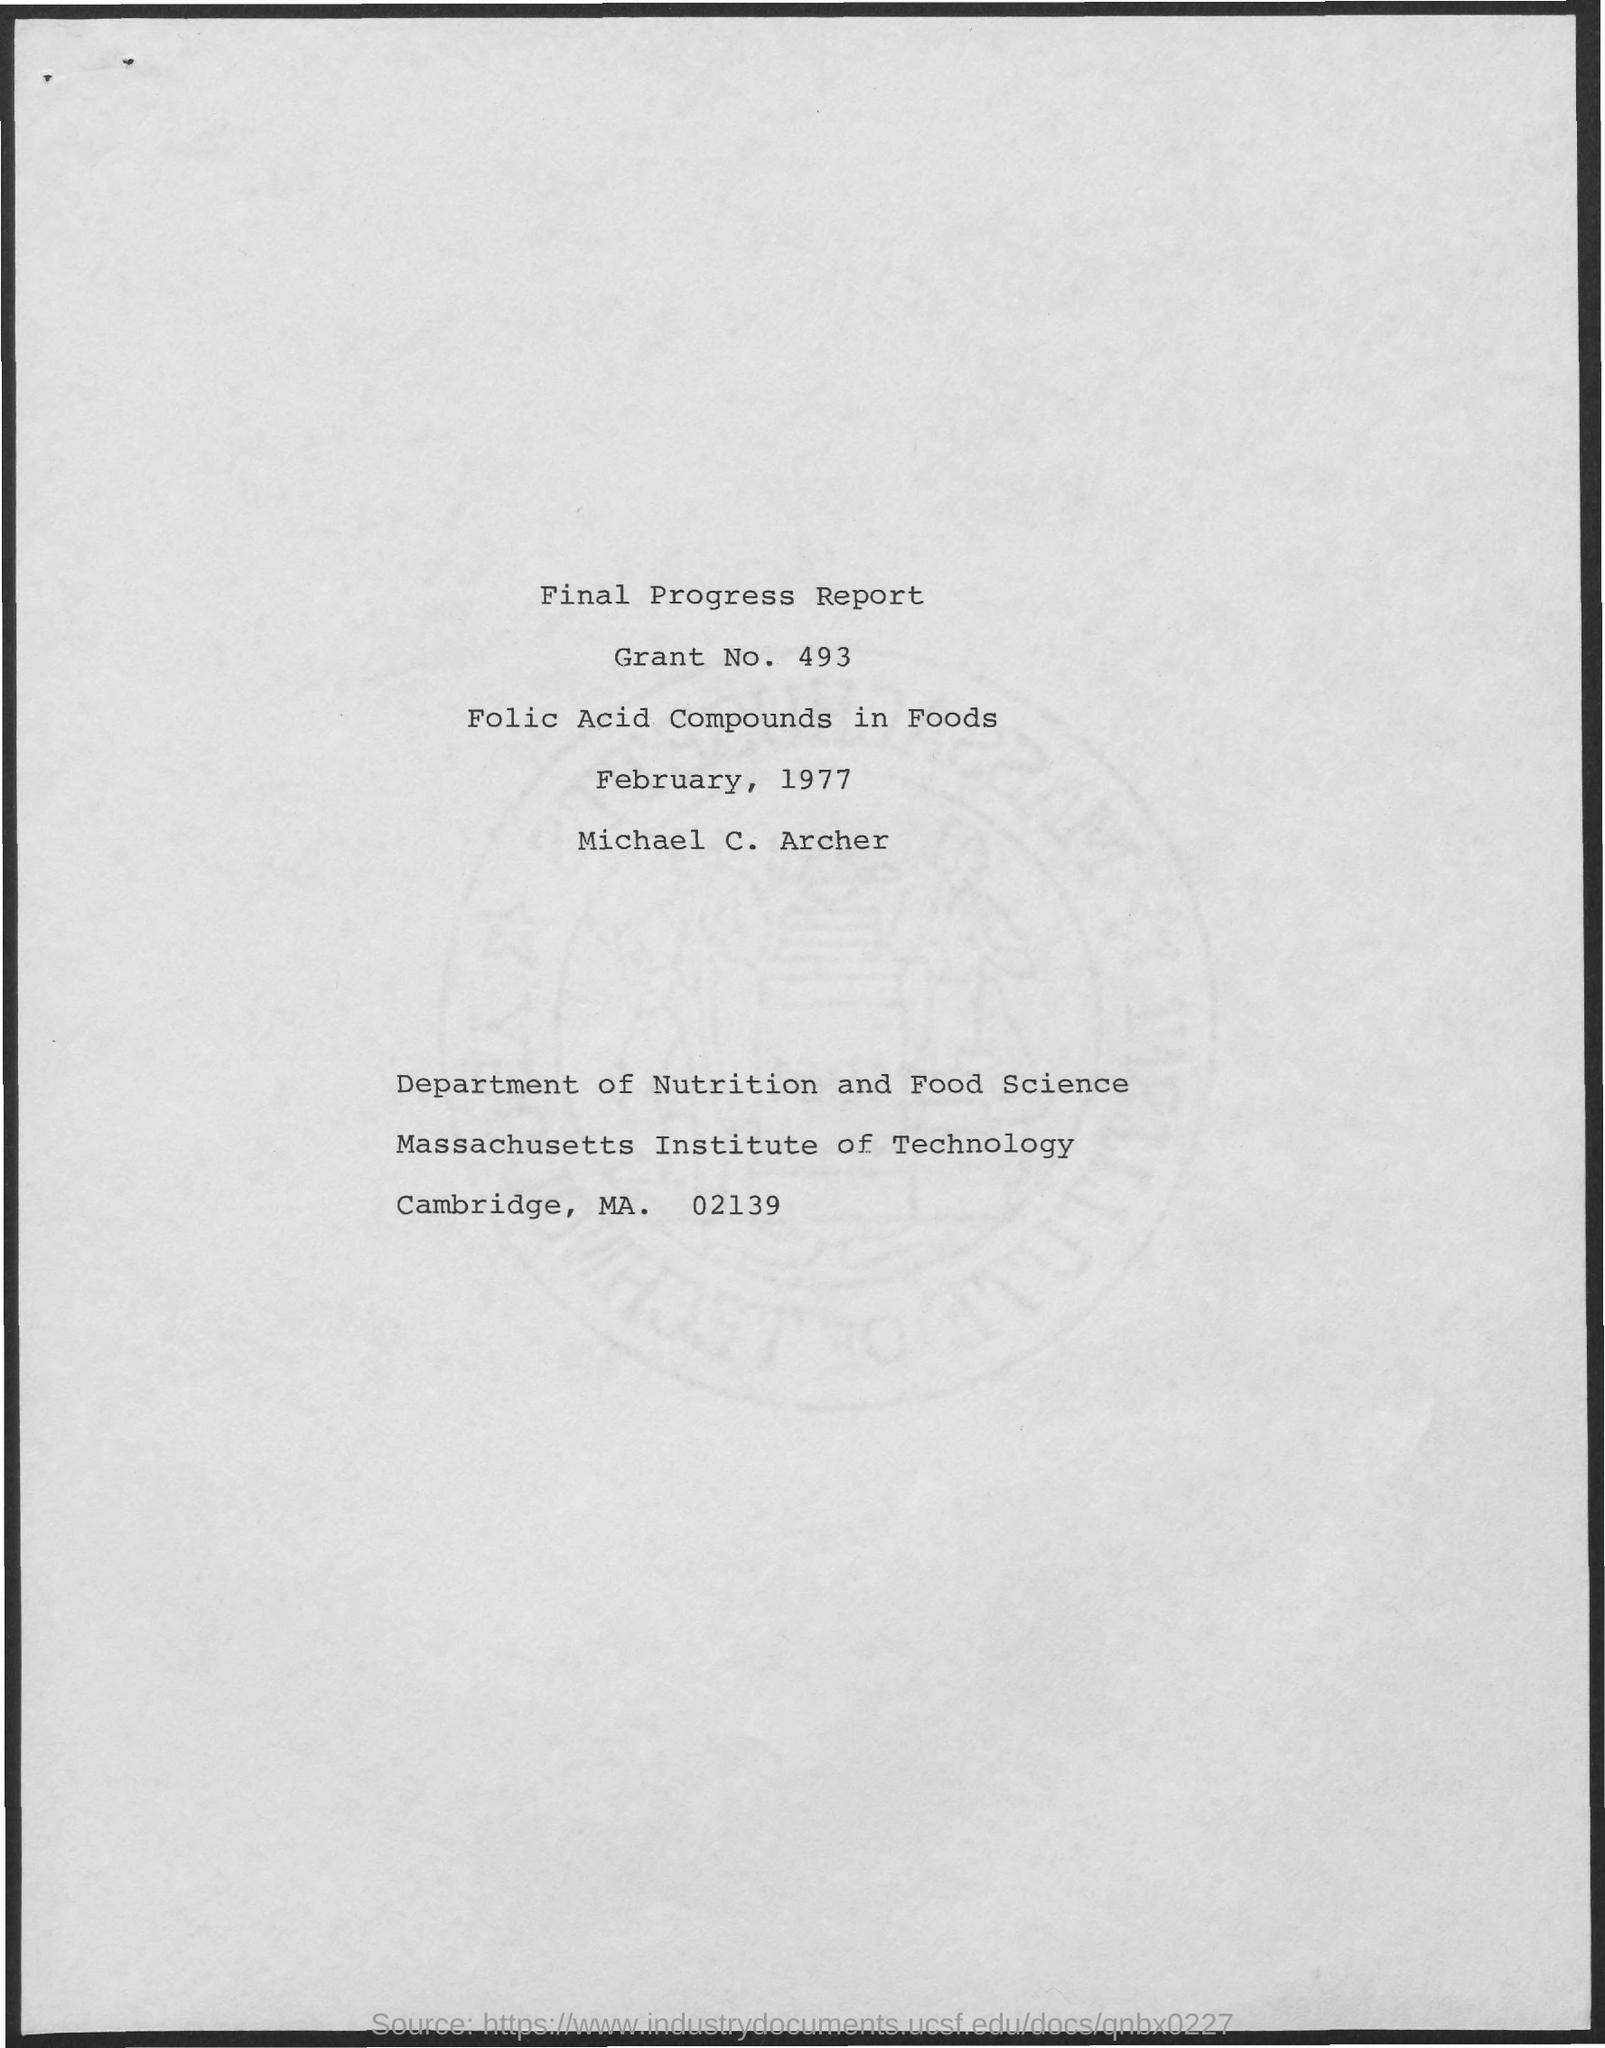What is the Grant No. mentioned in this report?
Make the answer very short. 493. What is the date mentioned in this report?
Your answer should be compact. February, 1977. What is the article title given?
Ensure brevity in your answer.  Folic acid compounds in foods. What is the author name mentioned here?
Keep it short and to the point. Michael c. archer. 